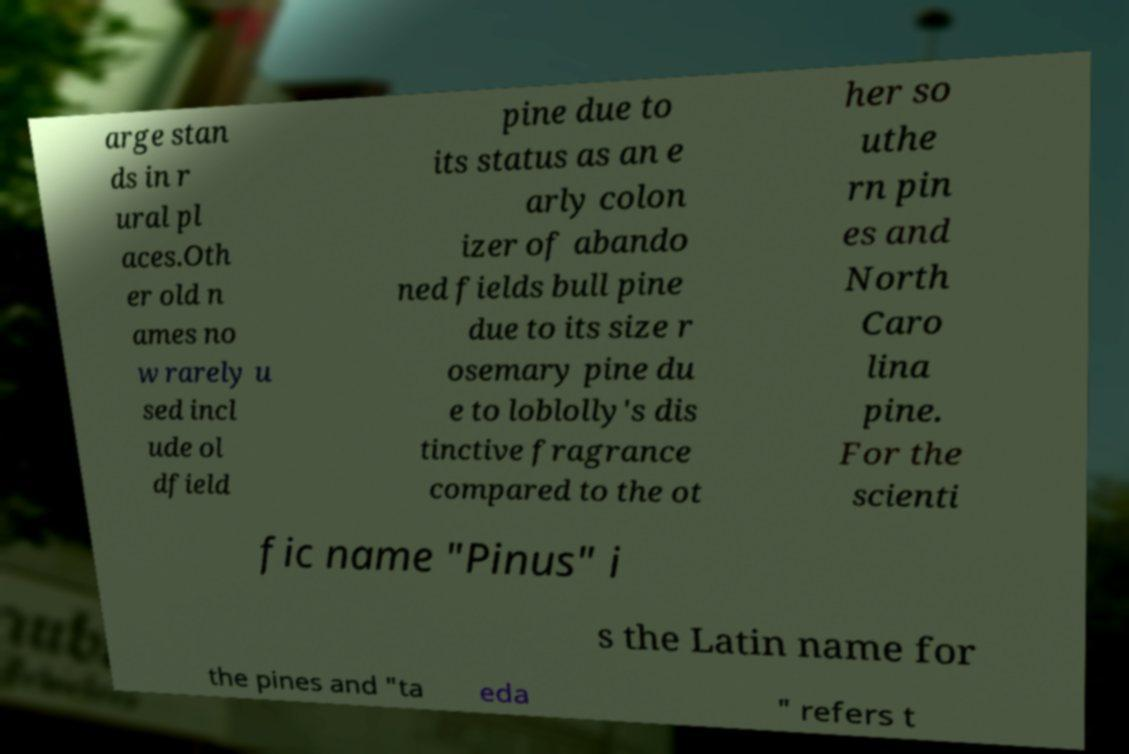Can you read and provide the text displayed in the image?This photo seems to have some interesting text. Can you extract and type it out for me? arge stan ds in r ural pl aces.Oth er old n ames no w rarely u sed incl ude ol dfield pine due to its status as an e arly colon izer of abando ned fields bull pine due to its size r osemary pine du e to loblolly's dis tinctive fragrance compared to the ot her so uthe rn pin es and North Caro lina pine. For the scienti fic name "Pinus" i s the Latin name for the pines and "ta eda " refers t 